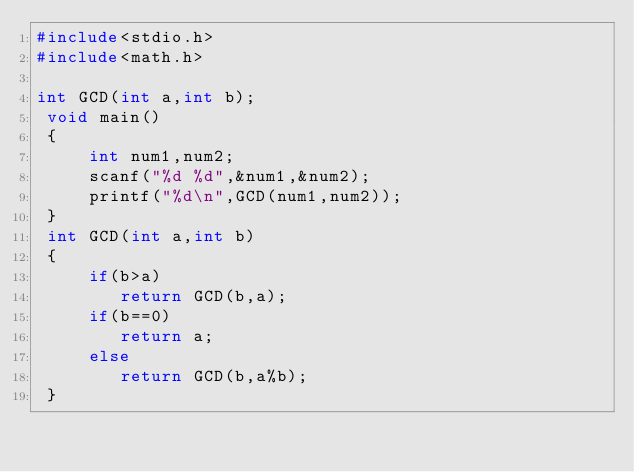Convert code to text. <code><loc_0><loc_0><loc_500><loc_500><_C_>#include<stdio.h>
#include<math.h>

int GCD(int a,int b);
 void main()
 {
     int num1,num2;
     scanf("%d %d",&num1,&num2);
     printf("%d\n",GCD(num1,num2));
 }
 int GCD(int a,int b)
 {
     if(b>a)
        return GCD(b,a);
     if(b==0)
        return a;
     else
        return GCD(b,a%b);
 }

</code> 